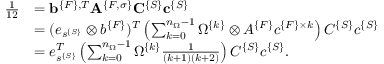Convert formula to latex. <formula><loc_0><loc_0><loc_500><loc_500>\begin{array} { r l } { \frac { 1 } { 1 2 } } & { = { b } ^ { \{ F \} , T } { A } ^ { \{ F , \sigma \} } { C } ^ { \{ S \} } { c } ^ { \{ S \} } } \\ & { = ( e _ { s ^ { \{ S \} } } \otimes b ^ { \{ F \} } ) ^ { T } \left ( \sum _ { k = 0 } ^ { n _ { \Omega } - 1 } \Omega ^ { \{ k \} } \otimes A ^ { \{ F \} } c ^ { \{ F \} \times k } \right ) C ^ { \{ S \} } c ^ { \{ S \} } } \\ & { = e _ { s ^ { \{ S \} } } ^ { T } \left ( \sum _ { k = 0 } ^ { n _ { \Omega } - 1 } \Omega ^ { \{ k \} } \frac { 1 } { ( k + 1 ) ( k + 2 ) } \right ) C ^ { \{ S \} } c ^ { \{ S \} } . } \end{array}</formula> 